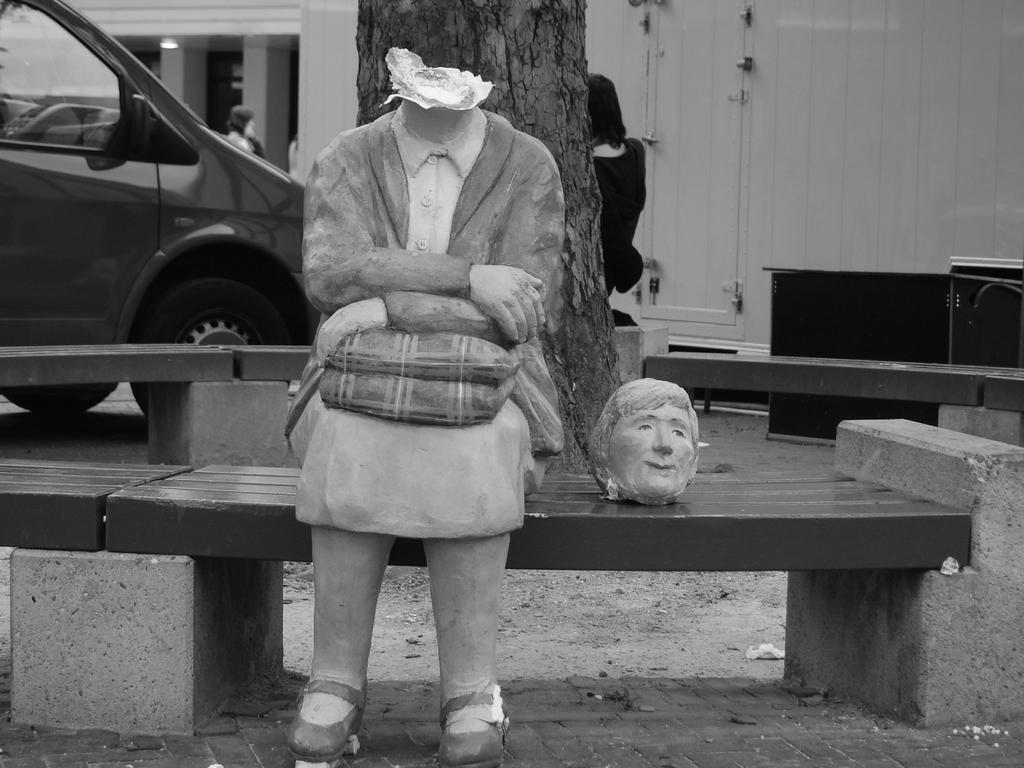Please provide a concise description of this image. In this black and white image I can see a statue or a toy sitting on a bench, the head part of this statue is broken and kept beside it. I can see a car, a person behind the car, some pillars. I can see a tree, a person behind the tree.  